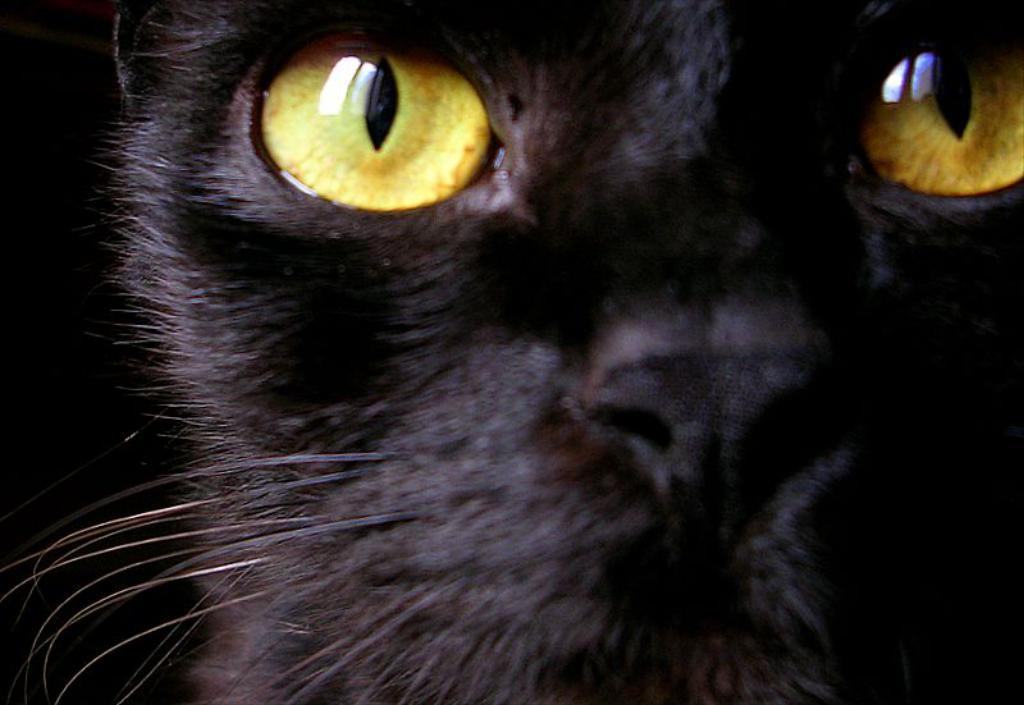What type of animal is in the image? There is a black cat in the image. What feature can be seen on the cat's eyes? There are yellow eye lenses in the image. What type of event is happening in the image? There is no event happening in the image; it simply features a black cat with yellow eye lenses. What type of underwear is the cat wearing in the image? Cats do not wear underwear, so this question cannot be answered definitively from the image. 